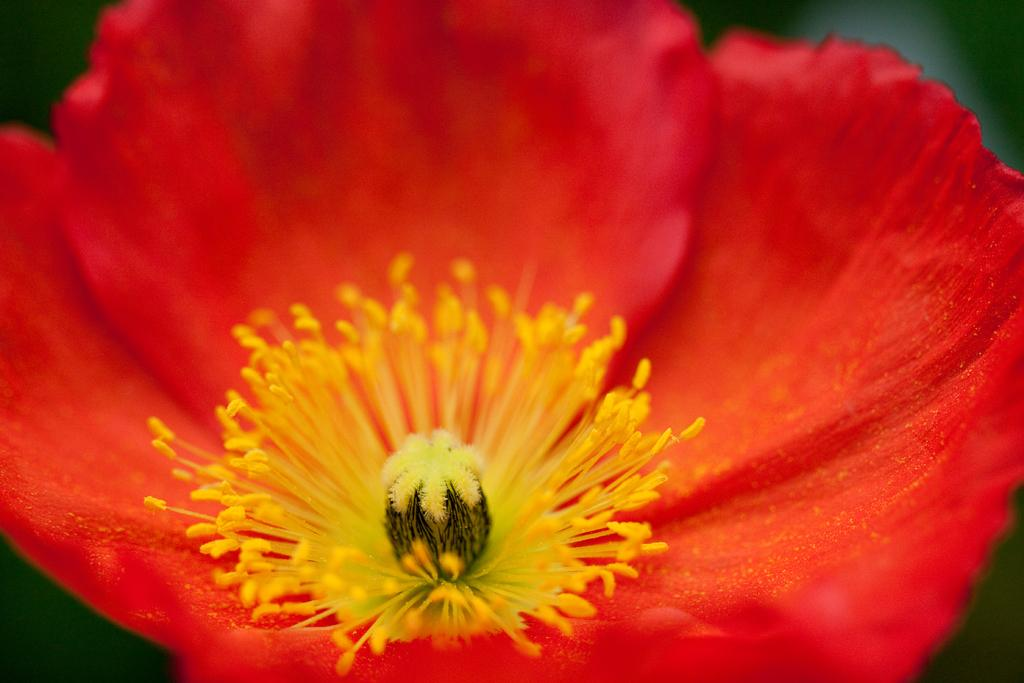What is the main subject of the image? There is a flower in the image. Where is the flower located in the image? The flower is in the center of the image. What colors can be seen on the flower? The flower has red and yellow colors. What type of bait is used to catch fish in the image? There is no mention of fish or bait in the image; it features a flower with red and yellow colors. 